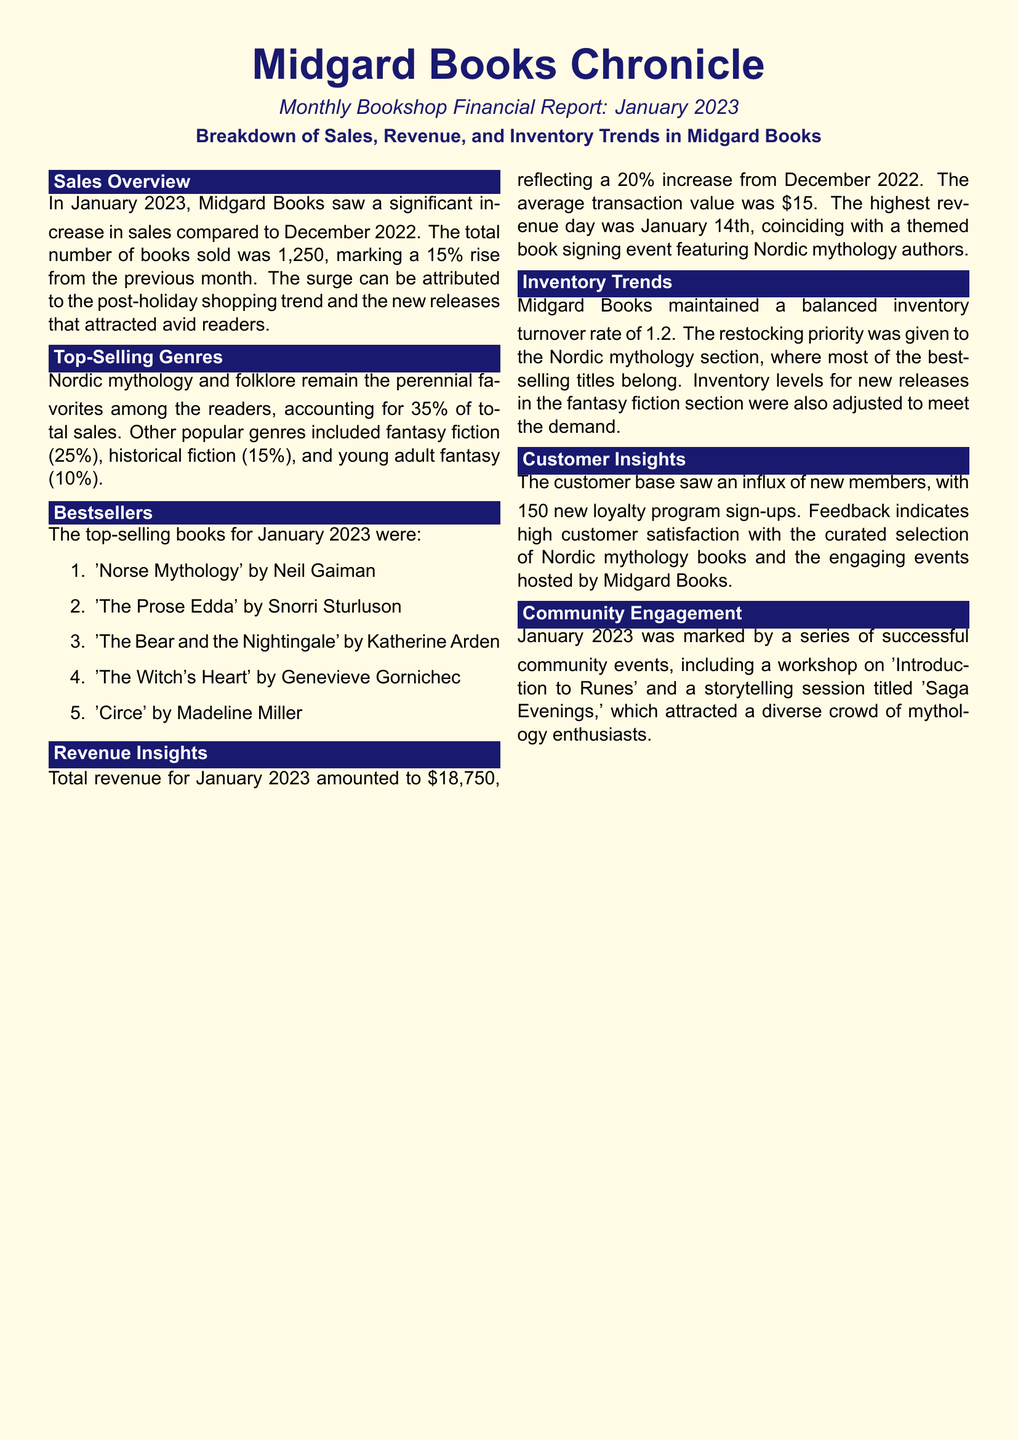What was the total number of books sold? The total number of books sold in January 2023 was 1,250, which shows an increase from December 2022.
Answer: 1,250 What was the total revenue for January 2023? The total revenue reported for January 2023 is provided in the revenue insights section, which notes a $18,750 amount.
Answer: $18,750 Which genre accounted for 35% of total sales? The document specifies that Nordic mythology and folklore account for this percentage in the sales overview.
Answer: Nordic mythology and folklore What was the average transaction value? The average transaction value is mentioned in the revenue insights section of the document, stating it as $15.
Answer: $15 When was the highest revenue day? The document indicates that the highest revenue day was January 14th, highlighting an event that occurred on that day.
Answer: January 14th What was a notable community event in January 2023? The document lists several community events, including a workshop and storytelling session, providing a significant example of these activities.
Answer: 'Introduction to Runes' How many new loyalty program sign-ups were there? The customer insights section states that there were 150 new sign-ups in the loyalty program during the month.
Answer: 150 Which book was a bestseller by Neil Gaiman? The document includes a ranking of bestselling books and names 'Norse Mythology' as the top-selling work by this author.
Answer: 'Norse Mythology' What was the inventory turnover rate? The inventory trends section of the document indicates that Midgard Books had a turnover rate of 1.2 during January 2023.
Answer: 1.2 What is the main theme of the top-selling genre? The sales overview points out that Nordic mythology and folklore are at the forefront among the genres sold.
Answer: Nordic mythology and folklore 